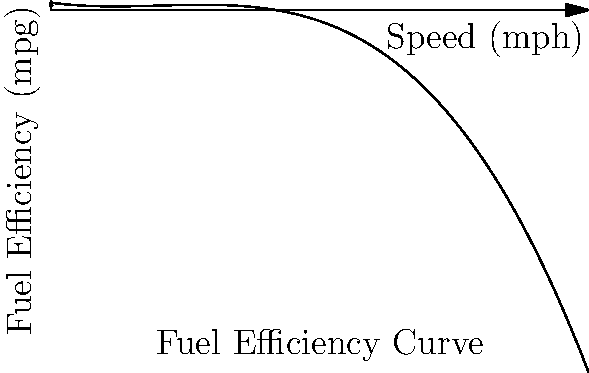The fuel efficiency curve of a delivery vehicle is represented by the polynomial function $f(x) = -0.02x^3 + 0.6x^2 - 5x + 25$, where $x$ is the speed in mph and $f(x)$ is the fuel efficiency in mpg. At what speed does the vehicle achieve maximum fuel efficiency, and what is this maximum efficiency? To find the maximum fuel efficiency, we need to follow these steps:

1) The maximum point occurs where the derivative of the function is zero. Let's find the derivative:
   $f'(x) = -0.06x^2 + 1.2x - 5$

2) Set the derivative equal to zero and solve:
   $-0.06x^2 + 1.2x - 5 = 0$

3) This is a quadratic equation. We can solve it using the quadratic formula:
   $x = \frac{-b \pm \sqrt{b^2 - 4ac}}{2a}$

   Where $a = -0.06$, $b = 1.2$, and $c = -5$

4) Plugging in these values:
   $x = \frac{-1.2 \pm \sqrt{1.44 - 4(-0.06)(-5)}}{2(-0.06)}$
   $x = \frac{-1.2 \pm \sqrt{1.44 - 1.2}}{-0.12}$
   $x = \frac{-1.2 \pm \sqrt{0.24}}{-0.12}$
   $x = \frac{-1.2 \pm 0.49}{-0.12}$

5) This gives us two solutions:
   $x_1 = \frac{-1.2 + 0.49}{-0.12} \approx 5.92$
   $x_2 = \frac{-1.2 - 0.49}{-0.12} \approx 14.08$

6) The second solution (14.08) is the maximum point, as we can verify by checking the second derivative or by looking at the graph.

7) To find the maximum efficiency, we plug this x-value back into our original function:
   $f(14.08) = -0.02(14.08)^3 + 0.6(14.08)^2 - 5(14.08) + 25 \approx 27.56$

Therefore, the maximum fuel efficiency is achieved at approximately 14.08 mph, and the maximum efficiency is approximately 27.56 mpg.
Answer: 14.08 mph, 27.56 mpg 